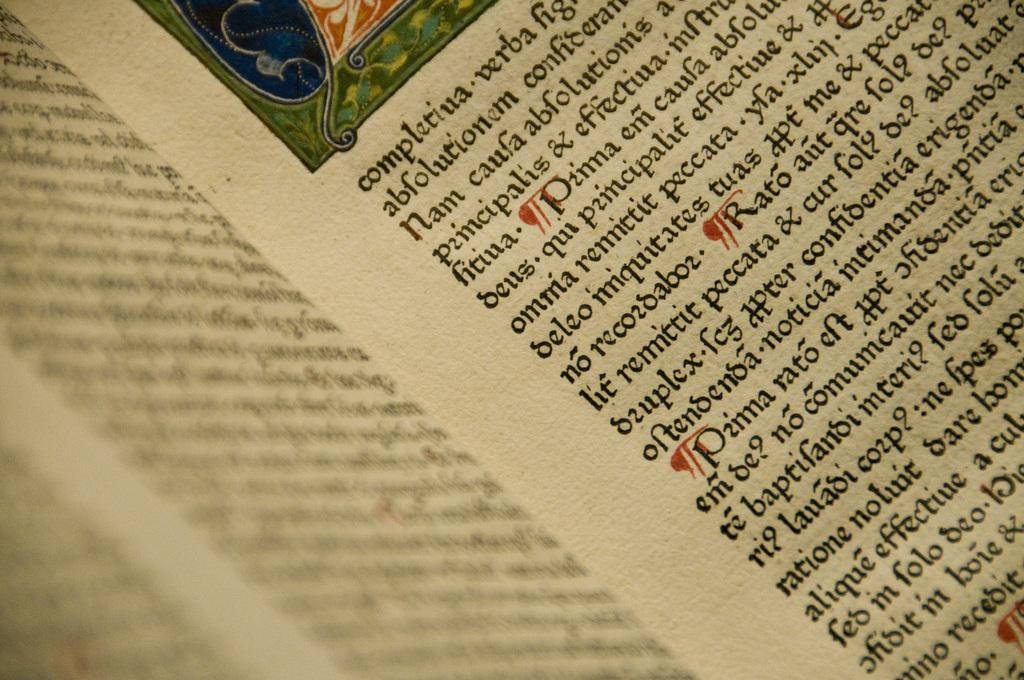<image>
Offer a succinct explanation of the picture presented. A book is open to a page with the first word completiua. 